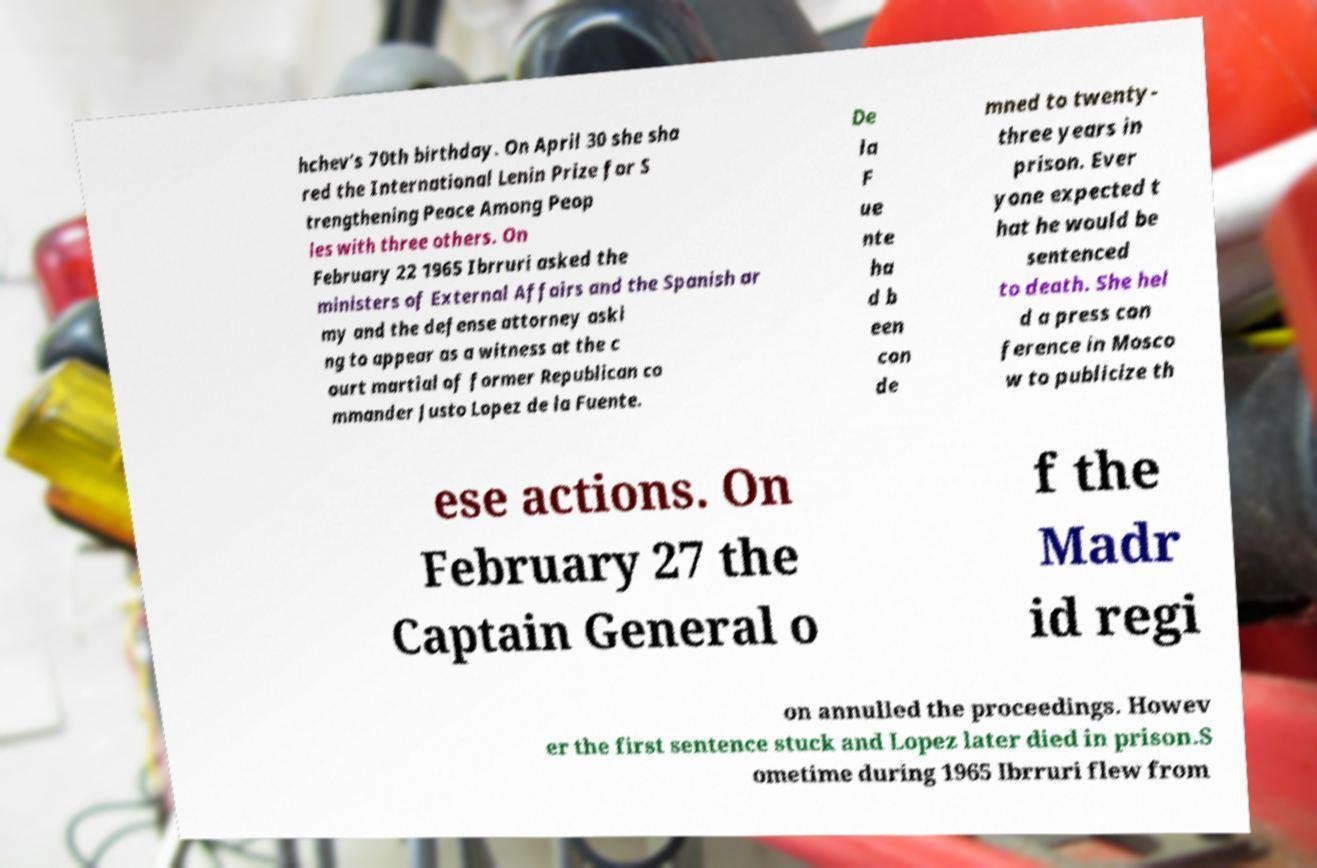What messages or text are displayed in this image? I need them in a readable, typed format. hchev's 70th birthday. On April 30 she sha red the International Lenin Prize for S trengthening Peace Among Peop les with three others. On February 22 1965 Ibrruri asked the ministers of External Affairs and the Spanish ar my and the defense attorney aski ng to appear as a witness at the c ourt martial of former Republican co mmander Justo Lopez de la Fuente. De la F ue nte ha d b een con de mned to twenty- three years in prison. Ever yone expected t hat he would be sentenced to death. She hel d a press con ference in Mosco w to publicize th ese actions. On February 27 the Captain General o f the Madr id regi on annulled the proceedings. Howev er the first sentence stuck and Lopez later died in prison.S ometime during 1965 Ibrruri flew from 